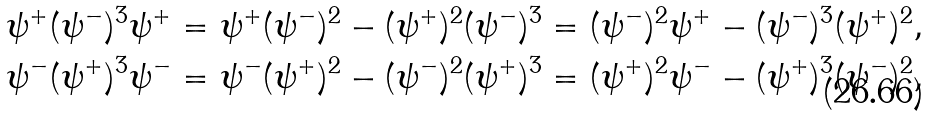Convert formula to latex. <formula><loc_0><loc_0><loc_500><loc_500>\psi ^ { + } ( \psi ^ { - } ) ^ { 3 } \psi ^ { + } & = \psi ^ { + } ( \psi ^ { - } ) ^ { 2 } - ( \psi ^ { + } ) ^ { 2 } ( \psi ^ { - } ) ^ { 3 } = ( \psi ^ { - } ) ^ { 2 } \psi ^ { + } - ( \psi ^ { - } ) ^ { 3 } ( \psi ^ { + } ) ^ { 2 } , \\ \psi ^ { - } ( \psi ^ { + } ) ^ { 3 } \psi ^ { - } & = \psi ^ { - } ( \psi ^ { + } ) ^ { 2 } - ( \psi ^ { - } ) ^ { 2 } ( \psi ^ { + } ) ^ { 3 } = ( \psi ^ { + } ) ^ { 2 } \psi ^ { - } - ( \psi ^ { + } ) ^ { 3 } ( \psi ^ { - } ) ^ { 2 } ,</formula> 